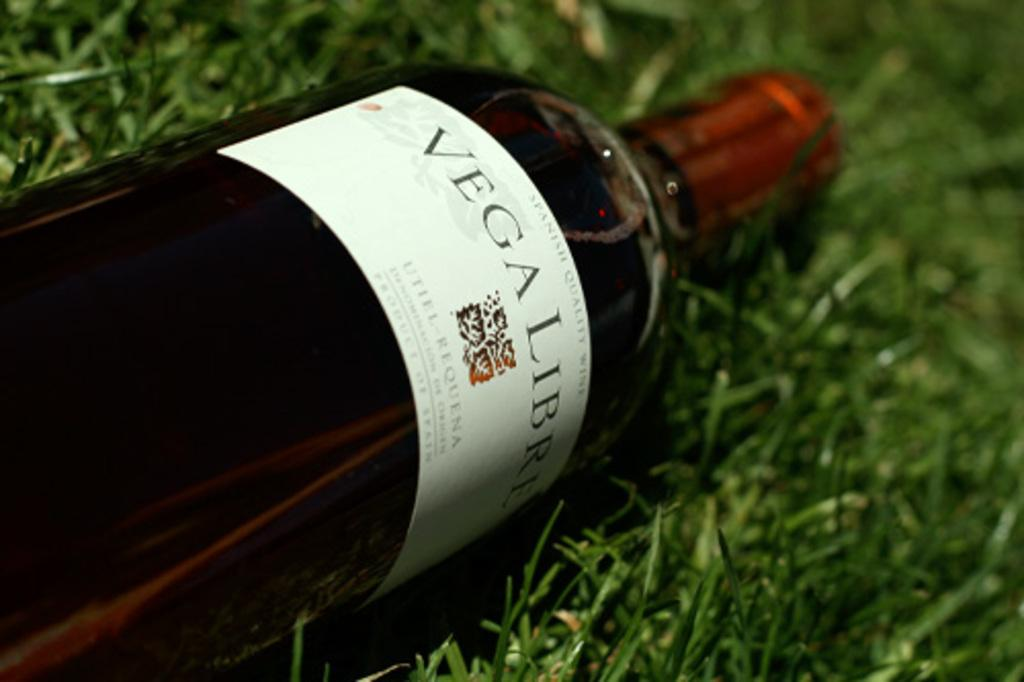Provide a one-sentence caption for the provided image. A bottle of "VEGALIBRE" is on the ground. 